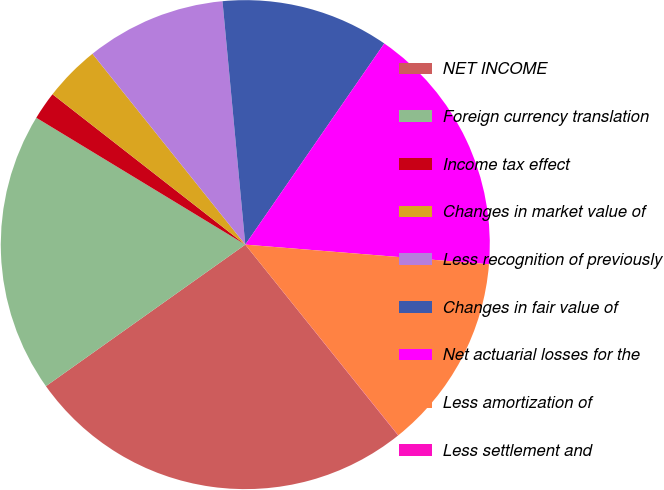<chart> <loc_0><loc_0><loc_500><loc_500><pie_chart><fcel>NET INCOME<fcel>Foreign currency translation<fcel>Income tax effect<fcel>Changes in market value of<fcel>Less recognition of previously<fcel>Changes in fair value of<fcel>Net actuarial losses for the<fcel>Less amortization of<fcel>Less settlement and<nl><fcel>25.92%<fcel>18.51%<fcel>1.86%<fcel>3.71%<fcel>9.26%<fcel>11.11%<fcel>16.66%<fcel>12.96%<fcel>0.01%<nl></chart> 